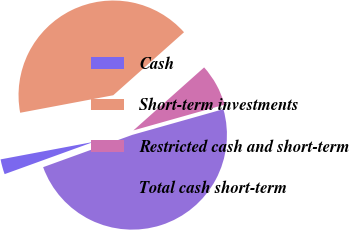<chart> <loc_0><loc_0><loc_500><loc_500><pie_chart><fcel>Cash<fcel>Short-term investments<fcel>Restricted cash and short-term<fcel>Total cash short-term<nl><fcel>2.57%<fcel>41.38%<fcel>7.2%<fcel>48.85%<nl></chart> 